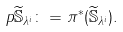<formula> <loc_0><loc_0><loc_500><loc_500>p \widetilde { \mathbb { S } } _ { \lambda ^ { i } } \colon = \pi ^ { * } ( \widetilde { \mathbb { S } } _ { \lambda ^ { i } } ) .</formula> 